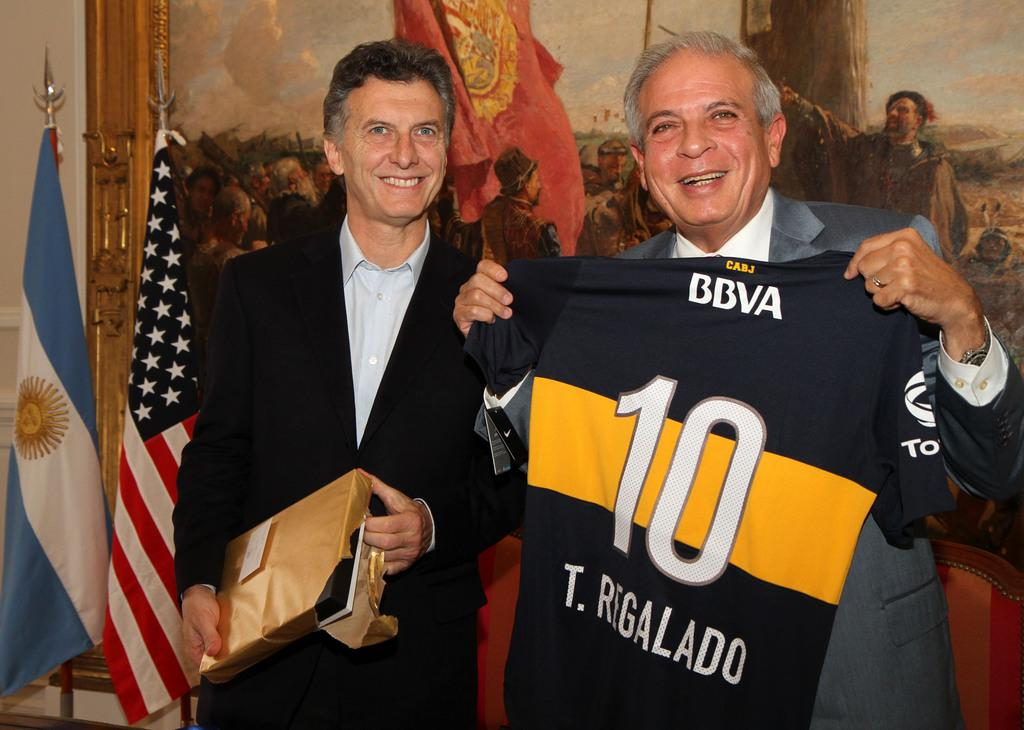<image>
Provide a brief description of the given image. A man is holding a jersey with the number 10 on it. 